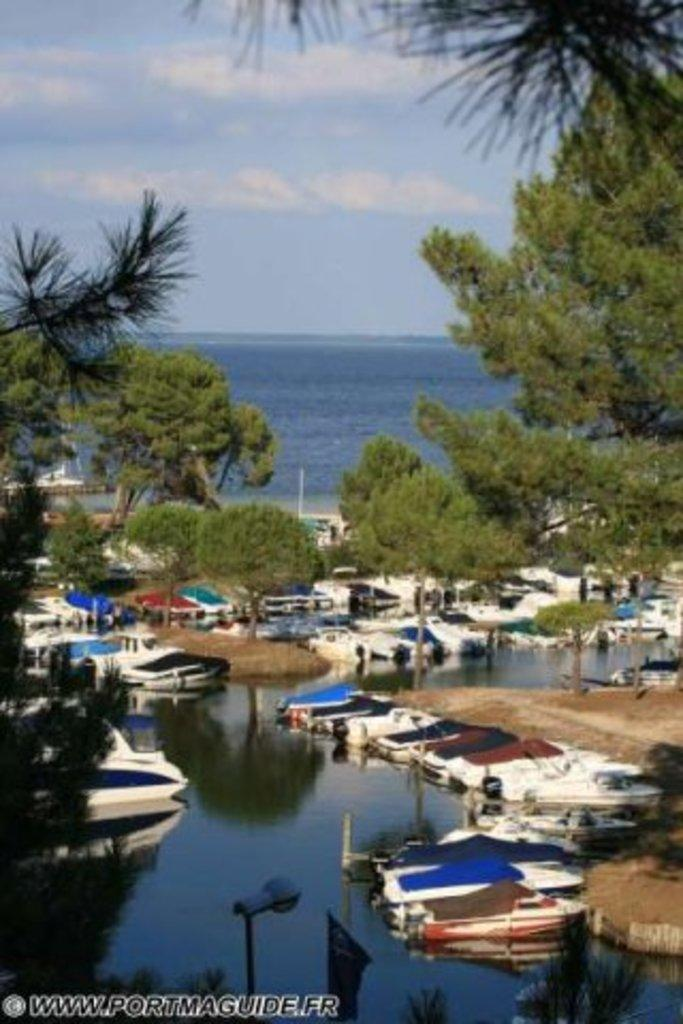What is the main subject in the center of the image? There is water in the center of the image. What is floating on the water? There are boats on the water. What can be seen in the background of the image? There are trees and an ocean in the background of the image. How would you describe the sky in the image? The sky is cloudy. How many horses can be seen grazing near the water in the image? There are no horses present in the image. Is there a donkey visible in the image? There is no donkey present in the image. 